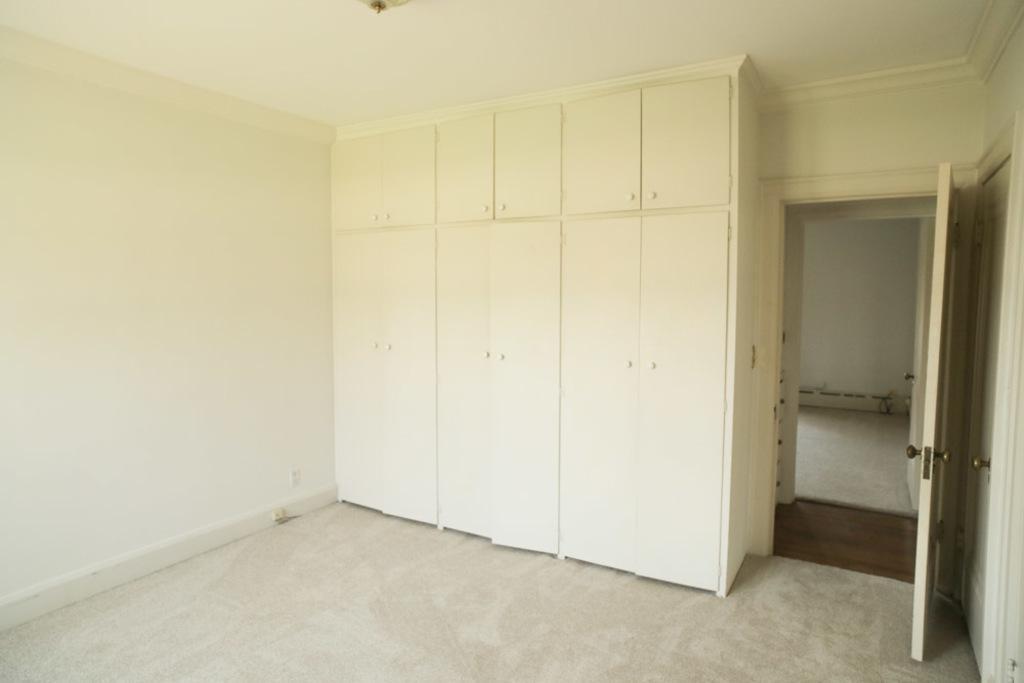How would you summarize this image in a sentence or two? In this image, we can see some cupboards, doors. We can also see the ground and the wall. We can see the roof. 